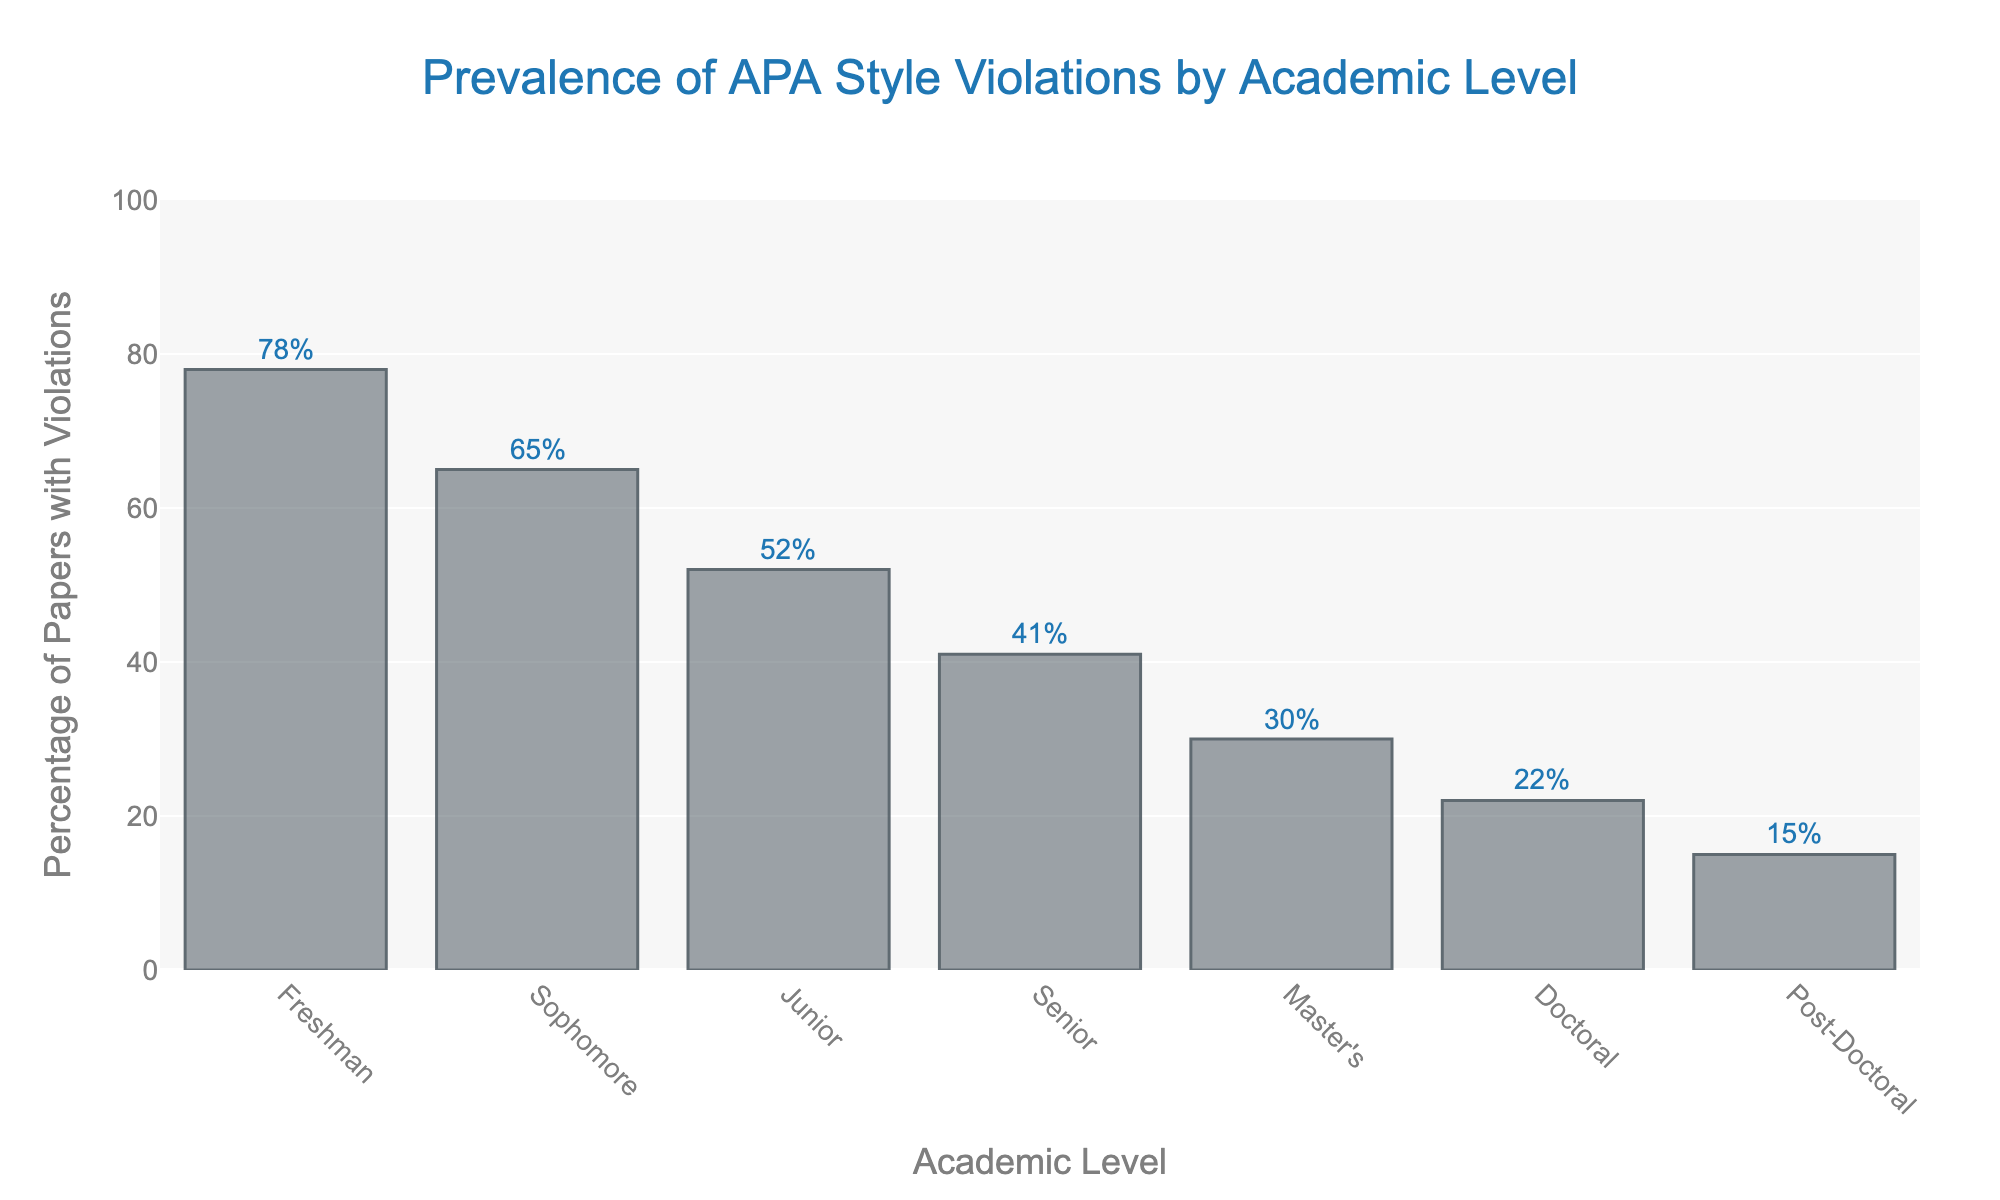What is the academic level with the highest percentage of APA style violations? The academic level with the highest bar indicates the one with the most violations. Here, the Freshman level has the highest bar at 78%.
Answer: Freshman Which academic level has the least percentage of APA style violations? The academic level with the shortest bar indicates the one with the least violations. The Post-Doctoral level has the shortest bar at 15%.
Answer: Post-Doctoral What is the difference in the percentage of APA style violations between Freshman and Senior levels? From the figure, Freshman has 78% and Senior has 41% of violations. The difference is calculated as 78 - 41 = 37.
Answer: 37 Compare the percentage of APA style violations between Sophomore and Master's levels. The height of the bars shows that Sophomore has 65% and Master's has 30%. Since 65 > 30, Sophomore has a higher percentage of violations than Master's.
Answer: Sophomore What is the average percentage of APA style violations for Freshman, Sophomore, and Junior levels? The average is found by summing the percentages for these levels: 78 (Freshman) + 65 (Sophomore) + 52 (Junior) = 195, then dividing by 3 gives 195/3 = 65%.
Answer: 65 Which has a higher percentage of APA style violations, Junior level or Doctoral level? Comparing the bars, the Junior level shows 52% while the Doctoral level shows 22%. As 52 > 22, Junior level has higher violations.
Answer: Junior What is the range of the percentage of APA style violations across all academic levels? The range is the difference between the highest and lowest percentages. The highest is 78% (Freshman) and the lowest is 15% (Post-Doctoral). So, the range is 78 - 15 = 63.
Answer: 63 How does the percentage of APA style violations change from Master's to Doctoral level? The percentage reduces from Master's (30%) to Doctoral (22%). Therefore, it decreases by 30 - 22 = 8%.
Answer: Decreases by 8 Arrange the academic levels in descending order of APA style violations. Ordering the values from highest to lowest: Freshman (78%), Sophomore (65%), Junior (52%), Senior (41%), Master's (30%), Doctoral (22%), Post-Doctoral (15%).
Answer: Freshman, Sophomore, Junior, Senior, Master's, Doctoral, Post-Doctoral 